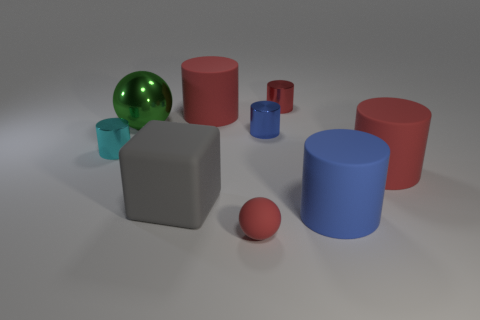Subtract all red balls. How many red cylinders are left? 3 Subtract all cyan cylinders. How many cylinders are left? 5 Subtract all small cyan metal cylinders. How many cylinders are left? 5 Subtract 2 cylinders. How many cylinders are left? 4 Subtract all green cylinders. Subtract all green balls. How many cylinders are left? 6 Add 1 yellow matte objects. How many objects exist? 10 Subtract all spheres. How many objects are left? 7 Subtract all blue objects. Subtract all red rubber objects. How many objects are left? 4 Add 4 red matte objects. How many red matte objects are left? 7 Add 6 big red cylinders. How many big red cylinders exist? 8 